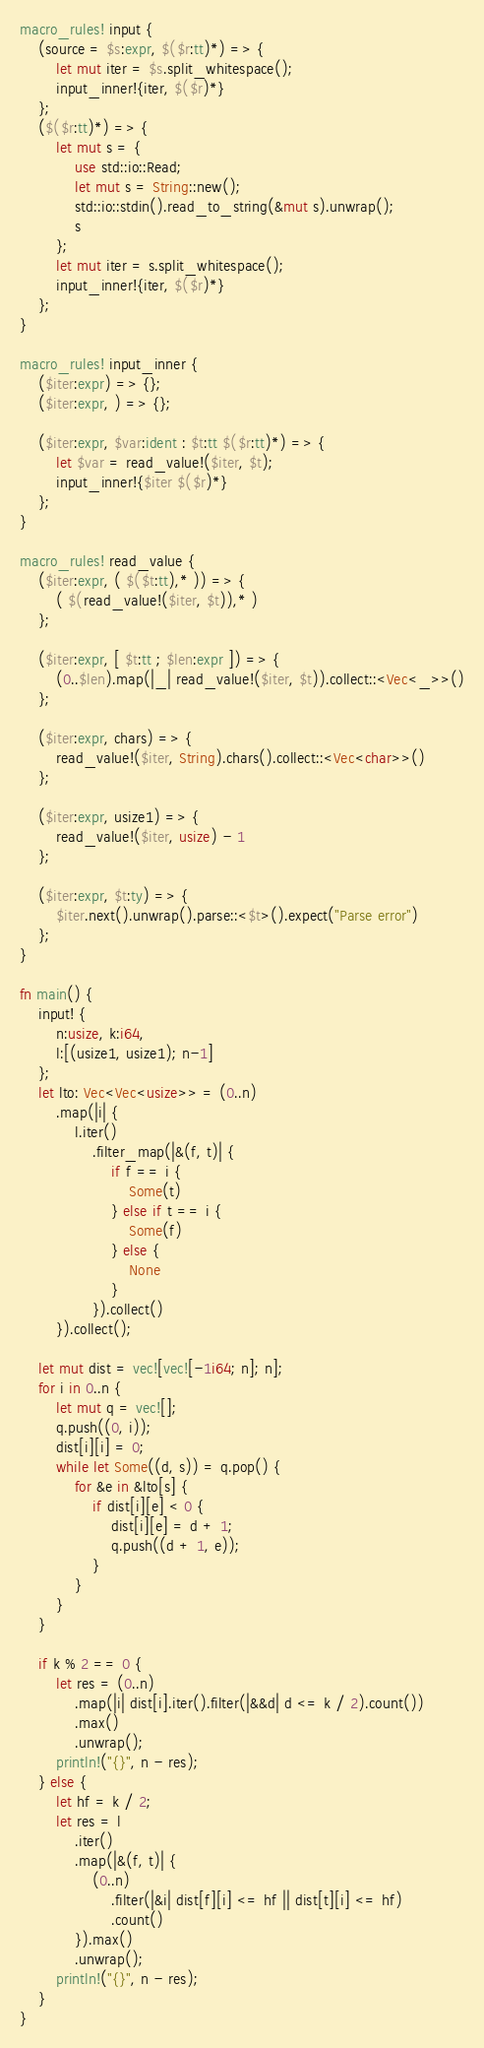<code> <loc_0><loc_0><loc_500><loc_500><_Rust_>macro_rules! input {
    (source = $s:expr, $($r:tt)*) => {
        let mut iter = $s.split_whitespace();
        input_inner!{iter, $($r)*}
    };
    ($($r:tt)*) => {
        let mut s = {
            use std::io::Read;
            let mut s = String::new();
            std::io::stdin().read_to_string(&mut s).unwrap();
            s
        };
        let mut iter = s.split_whitespace();
        input_inner!{iter, $($r)*}
    };
}

macro_rules! input_inner {
    ($iter:expr) => {};
    ($iter:expr, ) => {};

    ($iter:expr, $var:ident : $t:tt $($r:tt)*) => {
        let $var = read_value!($iter, $t);
        input_inner!{$iter $($r)*}
    };
}

macro_rules! read_value {
    ($iter:expr, ( $($t:tt),* )) => {
        ( $(read_value!($iter, $t)),* )
    };

    ($iter:expr, [ $t:tt ; $len:expr ]) => {
        (0..$len).map(|_| read_value!($iter, $t)).collect::<Vec<_>>()
    };

    ($iter:expr, chars) => {
        read_value!($iter, String).chars().collect::<Vec<char>>()
    };

    ($iter:expr, usize1) => {
        read_value!($iter, usize) - 1
    };

    ($iter:expr, $t:ty) => {
        $iter.next().unwrap().parse::<$t>().expect("Parse error")
    };
}

fn main() {
    input! {
        n:usize, k:i64,
        l:[(usize1, usize1); n-1]
    };
    let lto: Vec<Vec<usize>> = (0..n)
        .map(|i| {
            l.iter()
                .filter_map(|&(f, t)| {
                    if f == i {
                        Some(t)
                    } else if t == i {
                        Some(f)
                    } else {
                        None
                    }
                }).collect()
        }).collect();

    let mut dist = vec![vec![-1i64; n]; n];
    for i in 0..n {
        let mut q = vec![];
        q.push((0, i));
        dist[i][i] = 0;
        while let Some((d, s)) = q.pop() {
            for &e in &lto[s] {
                if dist[i][e] < 0 {
                    dist[i][e] = d + 1;
                    q.push((d + 1, e));
                }
            }
        }
    }

    if k % 2 == 0 {
        let res = (0..n)
            .map(|i| dist[i].iter().filter(|&&d| d <= k / 2).count())
            .max()
            .unwrap();
        println!("{}", n - res);
    } else {
        let hf = k / 2;
        let res = l
            .iter()
            .map(|&(f, t)| {
                (0..n)
                    .filter(|&i| dist[f][i] <= hf || dist[t][i] <= hf)
                    .count()
            }).max()
            .unwrap();
        println!("{}", n - res);
    }
}
</code> 